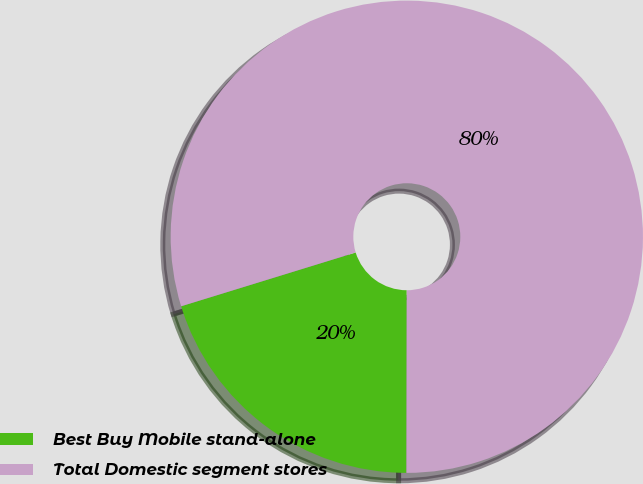Convert chart. <chart><loc_0><loc_0><loc_500><loc_500><pie_chart><fcel>Best Buy Mobile stand-alone<fcel>Total Domestic segment stores<nl><fcel>20.22%<fcel>79.78%<nl></chart> 